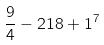<formula> <loc_0><loc_0><loc_500><loc_500>\frac { 9 } { 4 } - 2 1 8 + 1 ^ { 7 }</formula> 